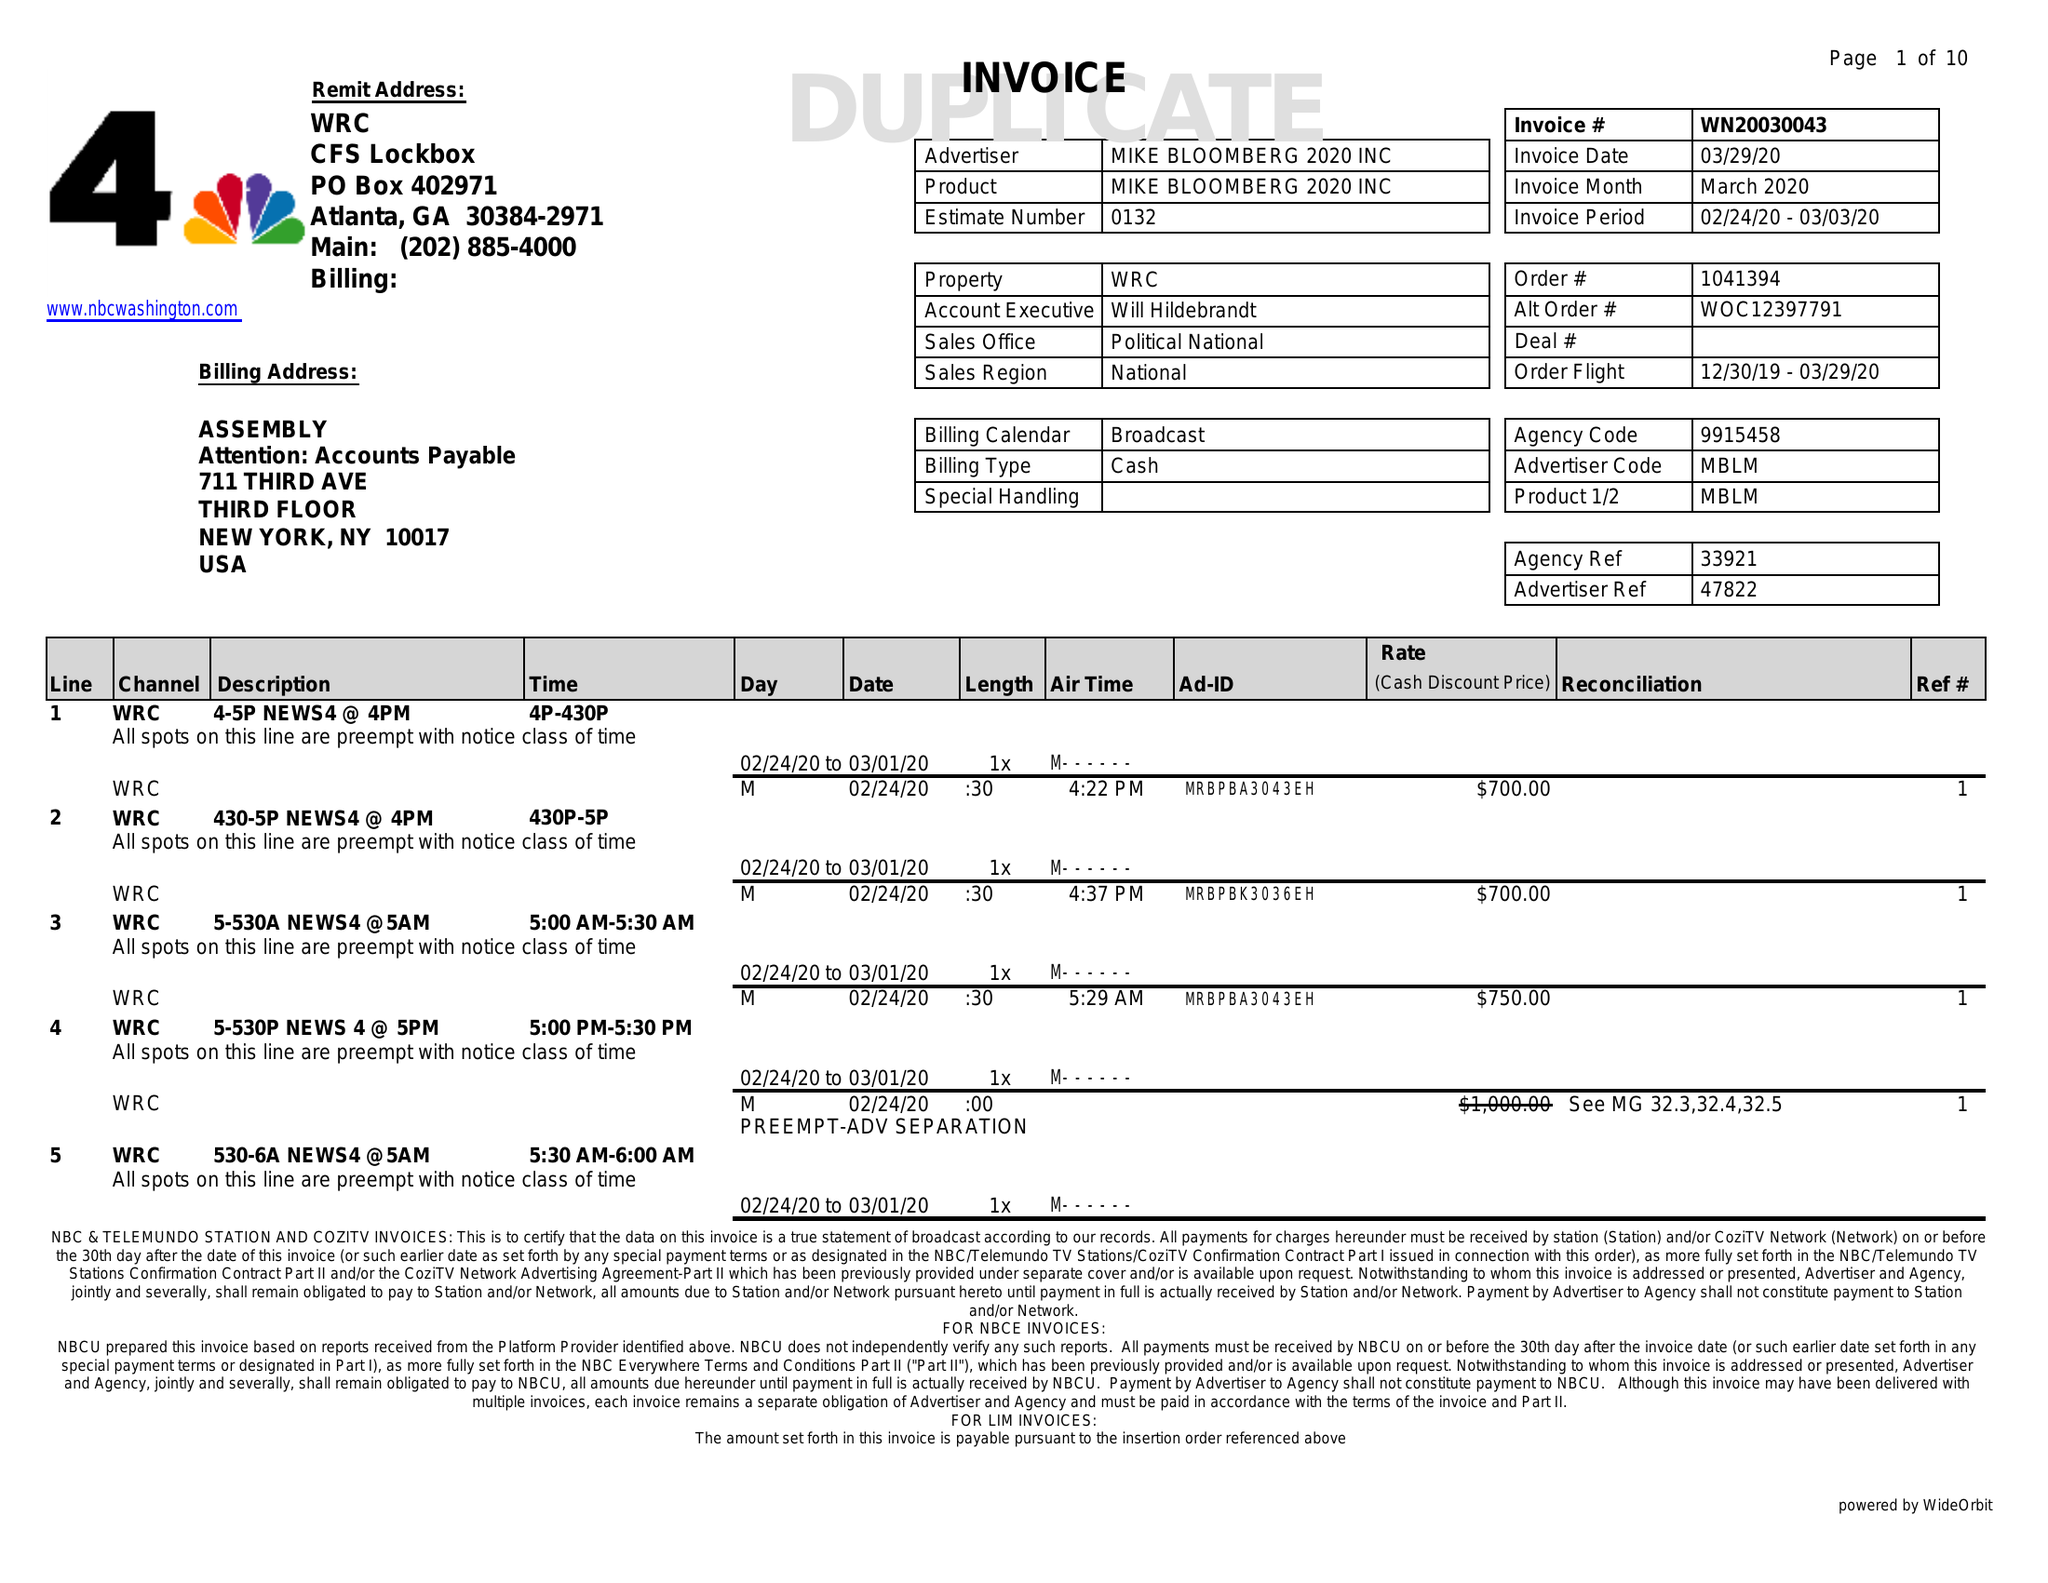What is the value for the flight_to?
Answer the question using a single word or phrase. 03/29/20 